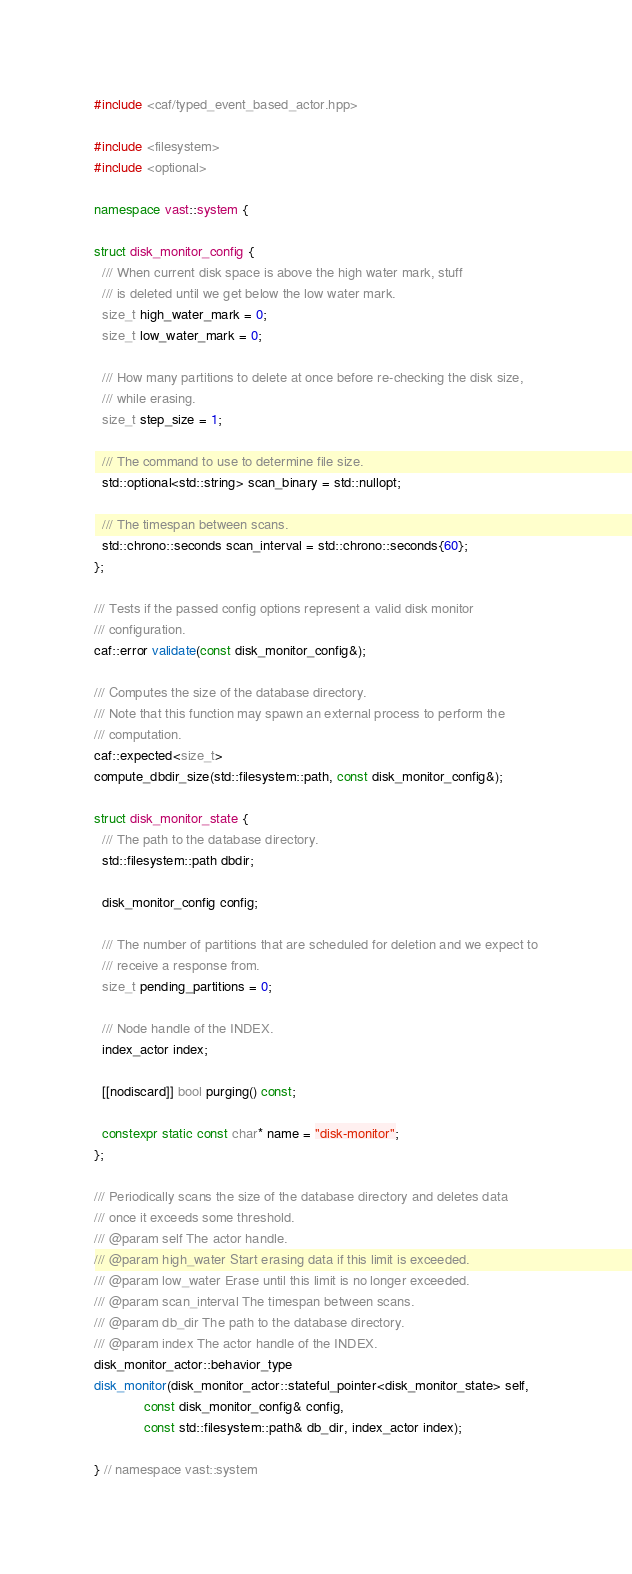<code> <loc_0><loc_0><loc_500><loc_500><_C++_>
#include <caf/typed_event_based_actor.hpp>

#include <filesystem>
#include <optional>

namespace vast::system {

struct disk_monitor_config {
  /// When current disk space is above the high water mark, stuff
  /// is deleted until we get below the low water mark.
  size_t high_water_mark = 0;
  size_t low_water_mark = 0;

  /// How many partitions to delete at once before re-checking the disk size,
  /// while erasing.
  size_t step_size = 1;

  /// The command to use to determine file size.
  std::optional<std::string> scan_binary = std::nullopt;

  /// The timespan between scans.
  std::chrono::seconds scan_interval = std::chrono::seconds{60};
};

/// Tests if the passed config options represent a valid disk monitor
/// configuration.
caf::error validate(const disk_monitor_config&);

/// Computes the size of the database directory.
/// Note that this function may spawn an external process to perform the
/// computation.
caf::expected<size_t>
compute_dbdir_size(std::filesystem::path, const disk_monitor_config&);

struct disk_monitor_state {
  /// The path to the database directory.
  std::filesystem::path dbdir;

  disk_monitor_config config;

  /// The number of partitions that are scheduled for deletion and we expect to
  /// receive a response from.
  size_t pending_partitions = 0;

  /// Node handle of the INDEX.
  index_actor index;

  [[nodiscard]] bool purging() const;

  constexpr static const char* name = "disk-monitor";
};

/// Periodically scans the size of the database directory and deletes data
/// once it exceeds some threshold.
/// @param self The actor handle.
/// @param high_water Start erasing data if this limit is exceeded.
/// @param low_water Erase until this limit is no longer exceeded.
/// @param scan_interval The timespan between scans.
/// @param db_dir The path to the database directory.
/// @param index The actor handle of the INDEX.
disk_monitor_actor::behavior_type
disk_monitor(disk_monitor_actor::stateful_pointer<disk_monitor_state> self,
             const disk_monitor_config& config,
             const std::filesystem::path& db_dir, index_actor index);

} // namespace vast::system
</code> 